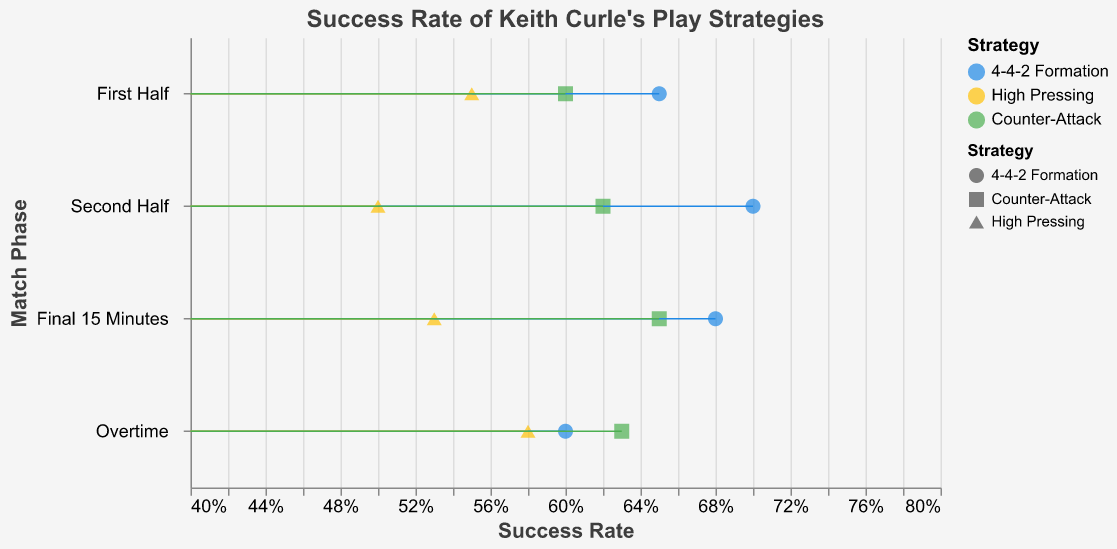What is the title of the figure? The title is usually at the top of the figure and summarizes what the data representation is about. Here, the title indicates the focus on the success rate of different play strategies implemented by Keith Curle.
Answer: Success Rate of Keith Curle's Play Strategies What is the success rate of the 4-4-2 Formation in the First Half? Locate the "First Half" phase on the y-axis and identify the dot corresponding to the 4-4-2 Formation. The x-axis value gives the success rate.
Answer: 0.65 Which phase shows the highest success rate for High Pressing? Compare the success rates for High Pressing across all game phases. The dot with the highest x-axis value on the line for High Pressing will indicate this.
Answer: Overtime What is the average success rate of the 4-4-2 Formation across all phases? Average the success rates of the 4-4-2 Formation across First Half, Second Half, Final 15 Minutes, and Overtime: (0.65 + 0.70 + 0.68 + 0.60)/4 = 0.6575
Answer: 0.6575 How does the success rate of Counter-Attack in the Final 15 Minutes compare to that in Overtime? Compare the success rate of Counter-Attack in the Final 15 Minutes (0.65) with that in Overtime (0.63).
Answer: Higher in Final 15 Minutes Does High Pressing have a higher success rate in the Second Half or Overtime? Compare the success rates of High Pressing in the Second Half (0.50) and Overtime (0.58).
Answer: Overtime Which strategy has the lowest success rate in the Second Half? Look at the success rates of all strategies in the Second Half and find the minimum value (0.50 for High Pressing).
Answer: High Pressing What is the difference in success rate for Counter-Attack between the First Half and Second Half? Subtract the success rate of Counter-Attack in the First Half (0.60) from that in the Second Half (0.62): 0.62 - 0.60 = 0.02
Answer: 0.02 During which phase is the success rate for 4-4-2 Formation the highest? Compare the success rates for the 4-4-2 Formation across all phases. The highest value is in the Second Half (0.70).
Answer: Second Half How many strategies have their highest success rate in the Second Half? Check each strategy to identify where it has its highest success rate and count how many have their highest in the Second Half (4-4-2 Formation and Counter-Attack).
Answer: 2 